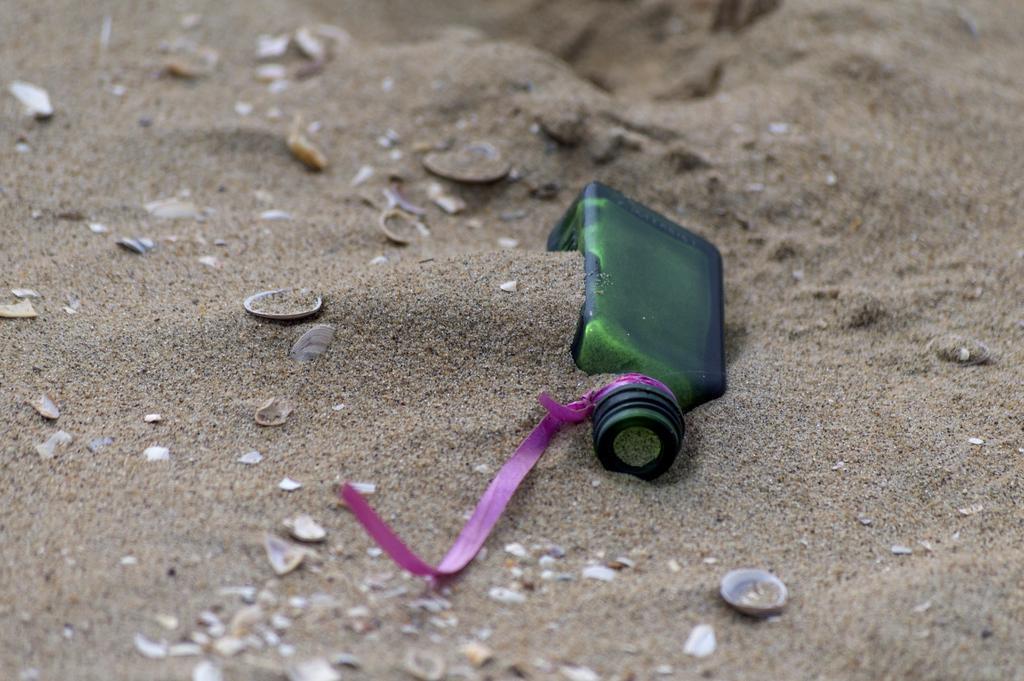Can you describe this image briefly? In this image I can see a bottle in the sand. 